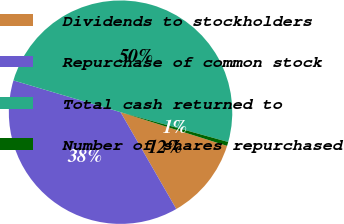Convert chart to OTSL. <chart><loc_0><loc_0><loc_500><loc_500><pie_chart><fcel>Dividends to stockholders<fcel>Repurchase of common stock<fcel>Total cash returned to<fcel>Number of shares repurchased<nl><fcel>11.81%<fcel>37.9%<fcel>49.71%<fcel>0.58%<nl></chart> 